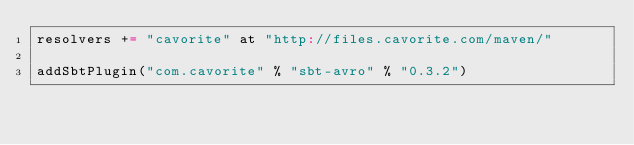<code> <loc_0><loc_0><loc_500><loc_500><_Scala_>resolvers += "cavorite" at "http://files.cavorite.com/maven/"

addSbtPlugin("com.cavorite" % "sbt-avro" % "0.3.2")</code> 